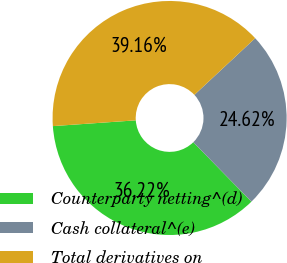Convert chart to OTSL. <chart><loc_0><loc_0><loc_500><loc_500><pie_chart><fcel>Counterparty netting^(d)<fcel>Cash collateral^(e)<fcel>Total derivatives on<nl><fcel>36.22%<fcel>24.62%<fcel>39.16%<nl></chart> 